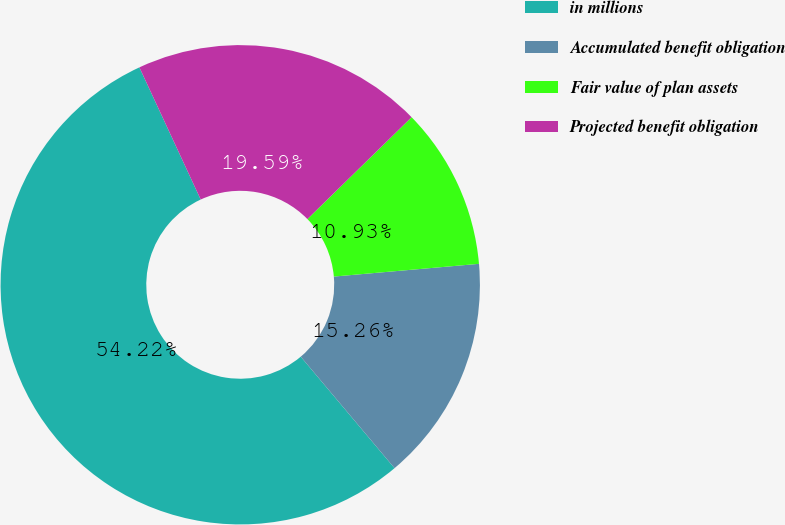Convert chart to OTSL. <chart><loc_0><loc_0><loc_500><loc_500><pie_chart><fcel>in millions<fcel>Accumulated benefit obligation<fcel>Fair value of plan assets<fcel>Projected benefit obligation<nl><fcel>54.22%<fcel>15.26%<fcel>10.93%<fcel>19.59%<nl></chart> 